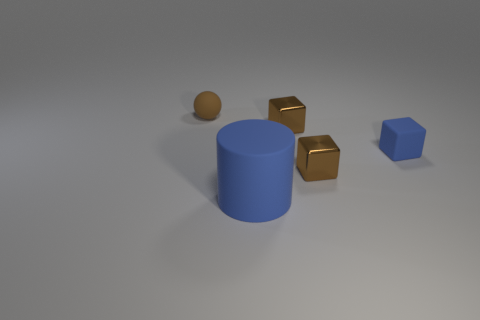What number of big objects are either rubber cylinders or cubes?
Offer a terse response. 1. What material is the tiny blue thing?
Offer a terse response. Rubber. What number of other objects are the same shape as the tiny blue rubber object?
Give a very brief answer. 2. What is the size of the brown rubber object?
Ensure brevity in your answer.  Small. How big is the rubber object that is to the right of the tiny brown sphere and on the left side of the small blue matte block?
Give a very brief answer. Large. There is a matte thing on the right side of the blue matte cylinder; what is its shape?
Give a very brief answer. Cube. Is the material of the large blue cylinder the same as the blue object to the right of the big cylinder?
Make the answer very short. Yes. Is the big object the same shape as the tiny blue matte object?
Keep it short and to the point. No. What is the color of the rubber thing that is behind the cylinder and on the right side of the small brown rubber thing?
Provide a succinct answer. Blue. The small rubber block has what color?
Provide a succinct answer. Blue. 